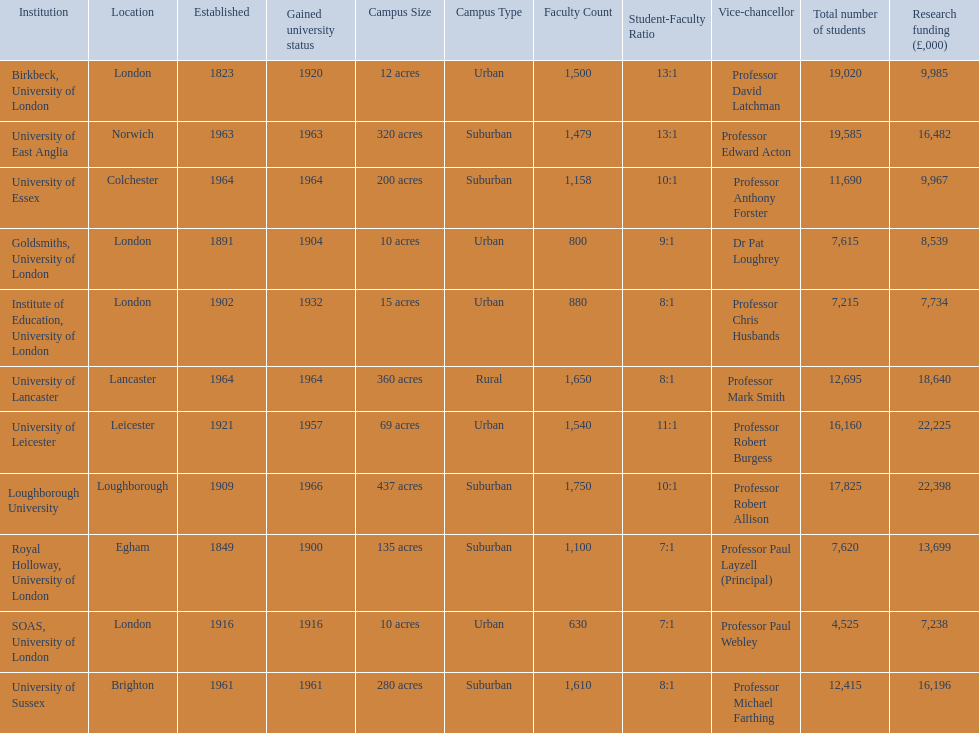What are the institutions in the 1994 group? Birkbeck, University of London, University of East Anglia, University of Essex, Goldsmiths, University of London, Institute of Education, University of London, University of Lancaster, University of Leicester, Loughborough University, Royal Holloway, University of London, SOAS, University of London, University of Sussex. Which of these was made a university most recently? Loughborough University. 